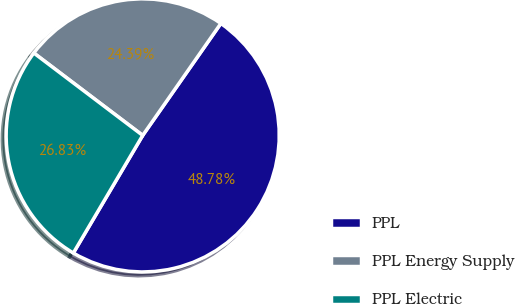<chart> <loc_0><loc_0><loc_500><loc_500><pie_chart><fcel>PPL<fcel>PPL Energy Supply<fcel>PPL Electric<nl><fcel>48.78%<fcel>24.39%<fcel>26.83%<nl></chart> 